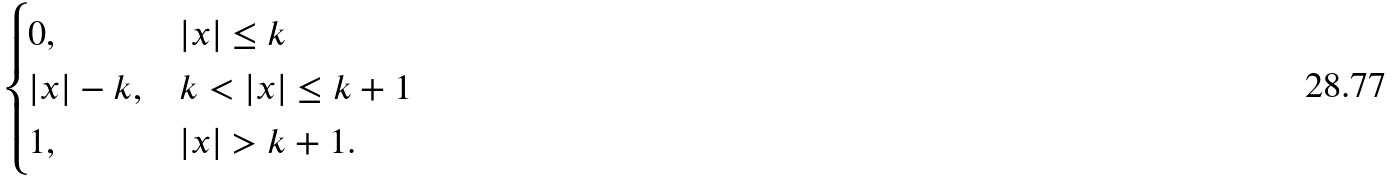<formula> <loc_0><loc_0><loc_500><loc_500>\begin{cases} 0 , & | x | \leq k \\ | x | - k , & k < | x | \leq k + 1 \\ 1 , & | x | > k + 1 . \end{cases}</formula> 